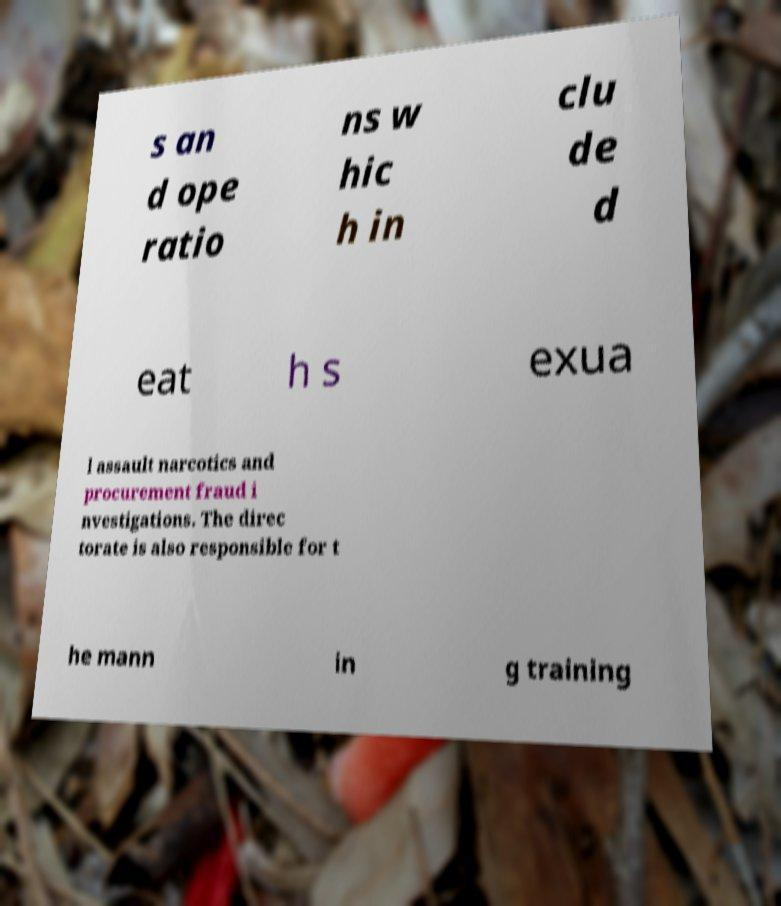There's text embedded in this image that I need extracted. Can you transcribe it verbatim? s an d ope ratio ns w hic h in clu de d eat h s exua l assault narcotics and procurement fraud i nvestigations. The direc torate is also responsible for t he mann in g training 